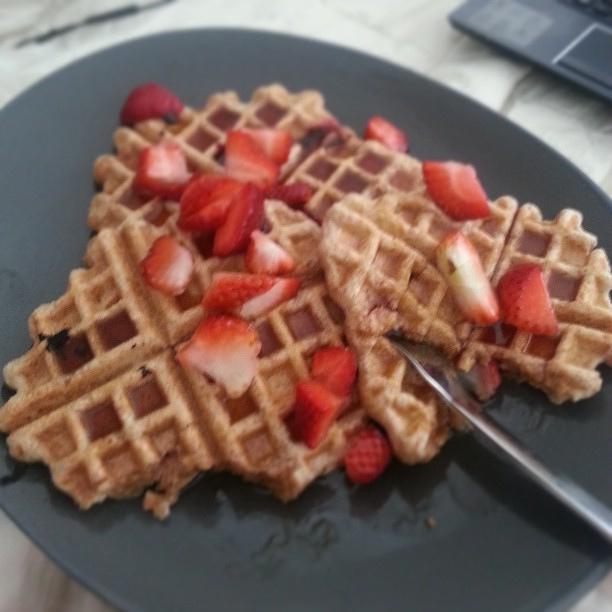What are the red items on the waffles?
Keep it brief. Strawberries. Do these waffles look buttered?
Keep it brief. No. What meal would this normally be served for?
Answer briefly. Breakfast. 